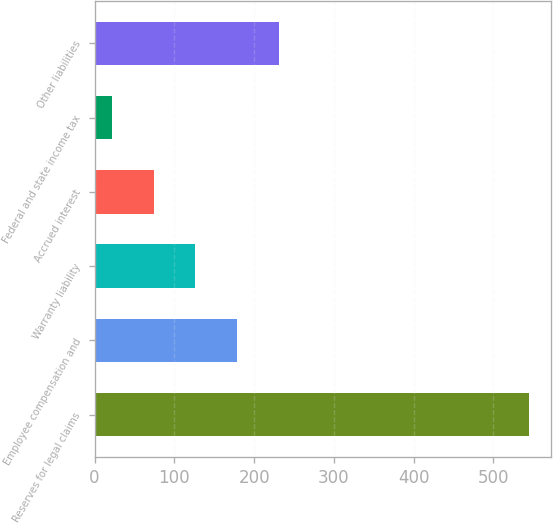Convert chart to OTSL. <chart><loc_0><loc_0><loc_500><loc_500><bar_chart><fcel>Reserves for legal claims<fcel>Employee compensation and<fcel>Warranty liability<fcel>Accrued interest<fcel>Federal and state income tax<fcel>Other liabilities<nl><fcel>544.9<fcel>178.59<fcel>126.26<fcel>73.93<fcel>21.6<fcel>230.92<nl></chart> 